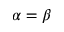Convert formula to latex. <formula><loc_0><loc_0><loc_500><loc_500>\alpha = \beta</formula> 